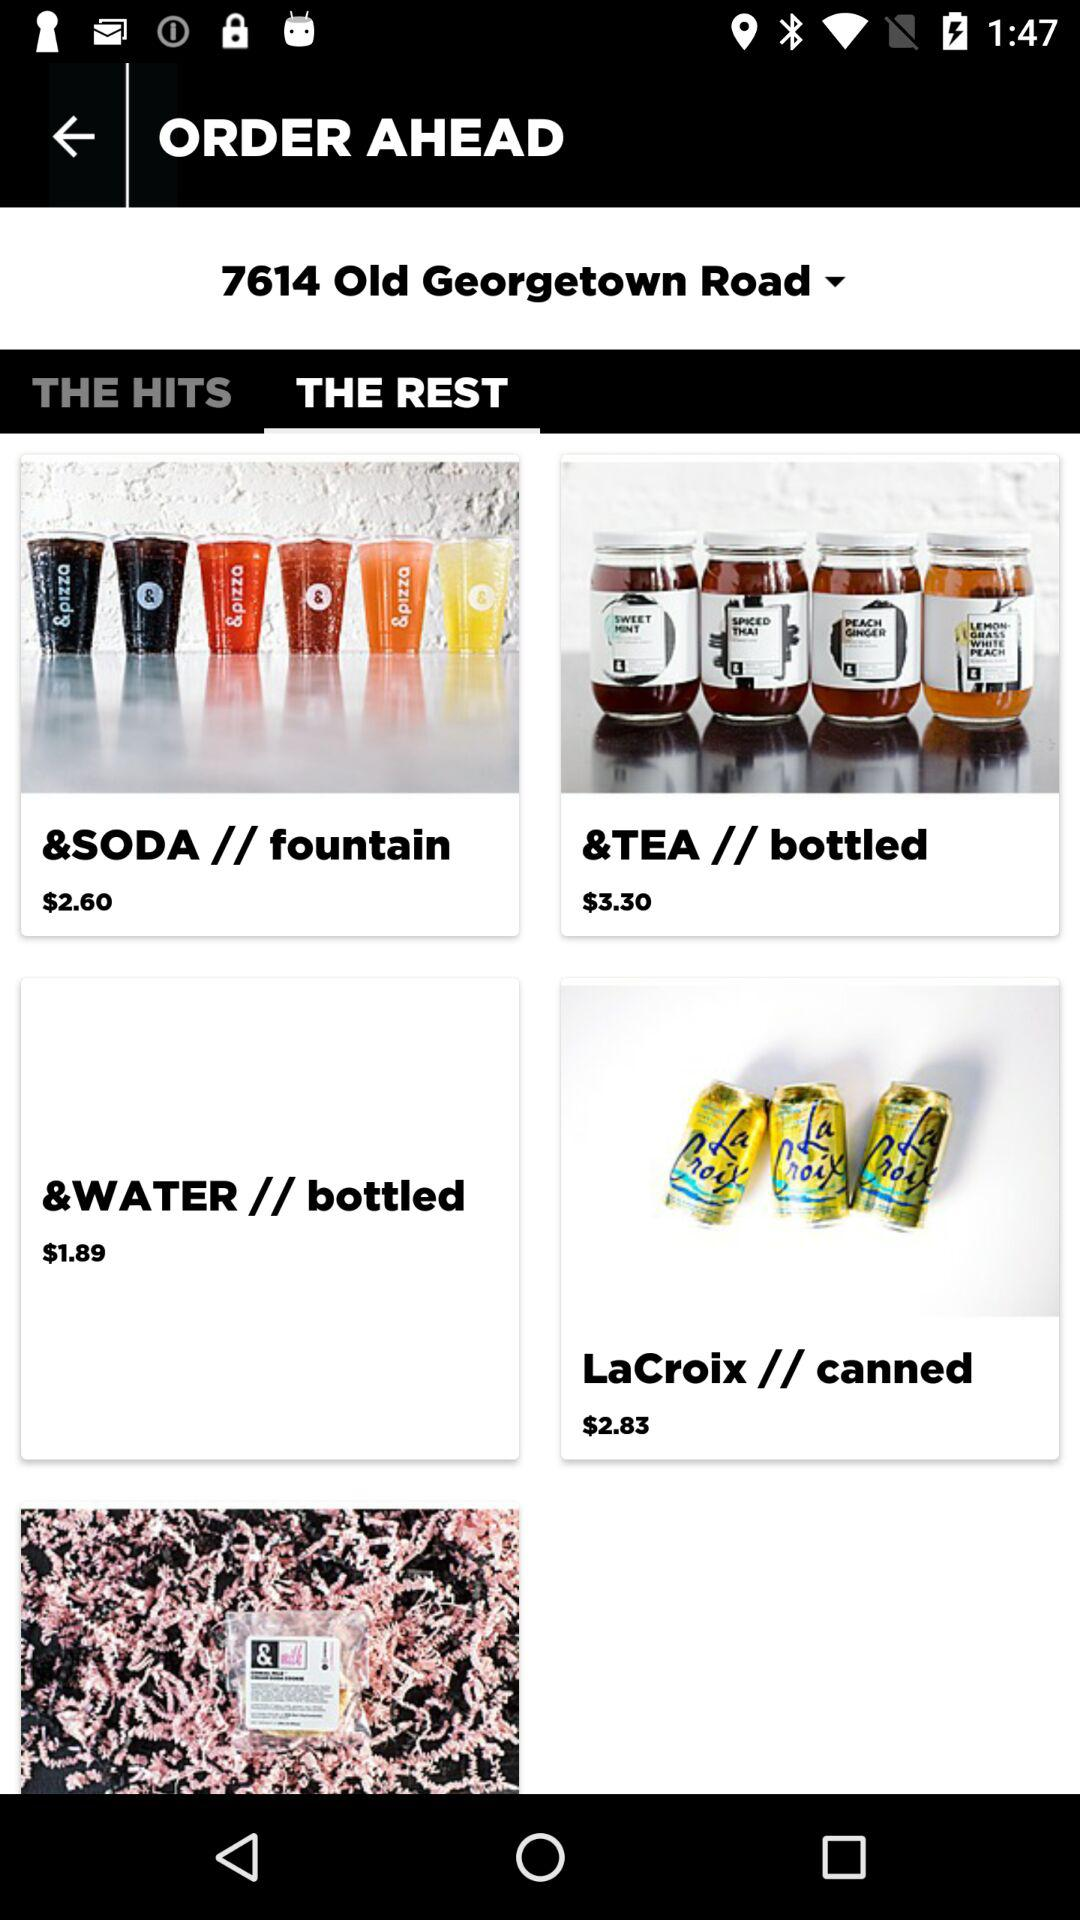What is the current location? The current location is 7614 Old Georgetown Road. 